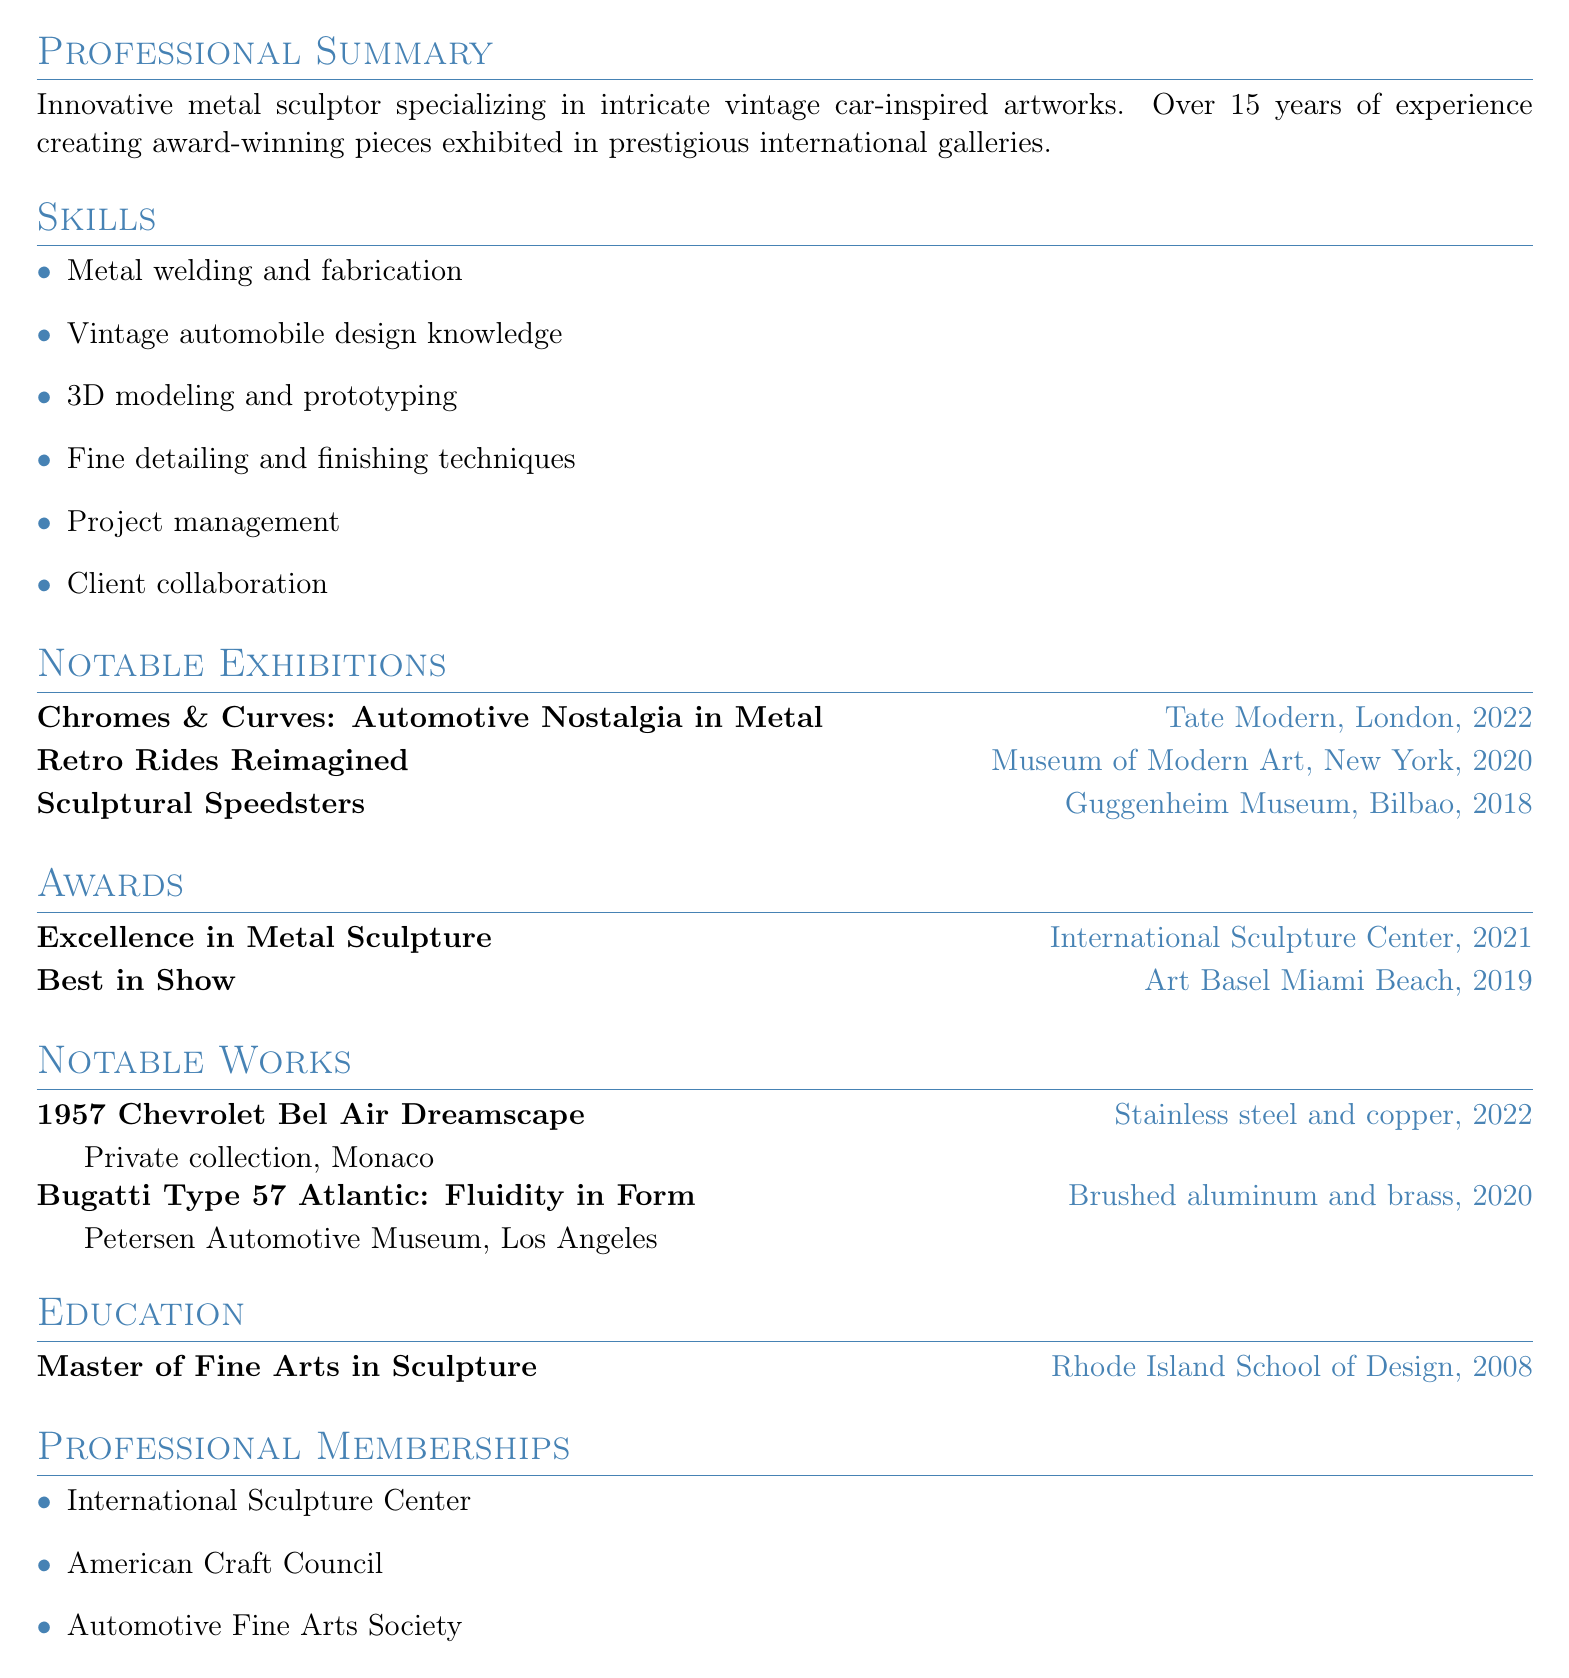what is the name of the artist? The document opens with the name of the artist at the top, which is Alexis Steele.
Answer: Alexis Steele what is the highest level of education completed? The education section lists the degree attained, which is a Master of Fine Arts in Sculpture.
Answer: Master of Fine Arts in Sculpture which award was received in 2021? The awards section highlights an award received in 2021, which is Excellence in Metal Sculpture.
Answer: Excellence in Metal Sculpture how many years of experience does the artist have? The professional summary states that the artist has over 15 years of experience in the field.
Answer: 15 years name a notable work from 2020. The notable works section lists a piece from 2020 titled Bugatti Type 57 Atlantic: Fluidity in Form.
Answer: Bugatti Type 57 Atlantic: Fluidity in Form where was the sculpture "Chromes & Curves: Automotive Nostalgia in Metal" exhibited? The exhibitions section indicates that this sculpture was exhibited at Tate Modern in London.
Answer: Tate Modern, London who is a member of the Automotive Fine Arts Society? The professional memberships section names the artist Alexis Steele as a member of this society.
Answer: Alexis Steele which city is the artist located in? The contact information shows that the artist is located in San Francisco, CA.
Answer: San Francisco, CA 